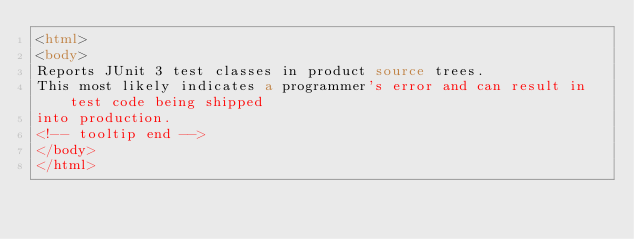<code> <loc_0><loc_0><loc_500><loc_500><_HTML_><html>
<body>
Reports JUnit 3 test classes in product source trees.
This most likely indicates a programmer's error and can result in test code being shipped
into production.
<!-- tooltip end -->
</body>
</html></code> 